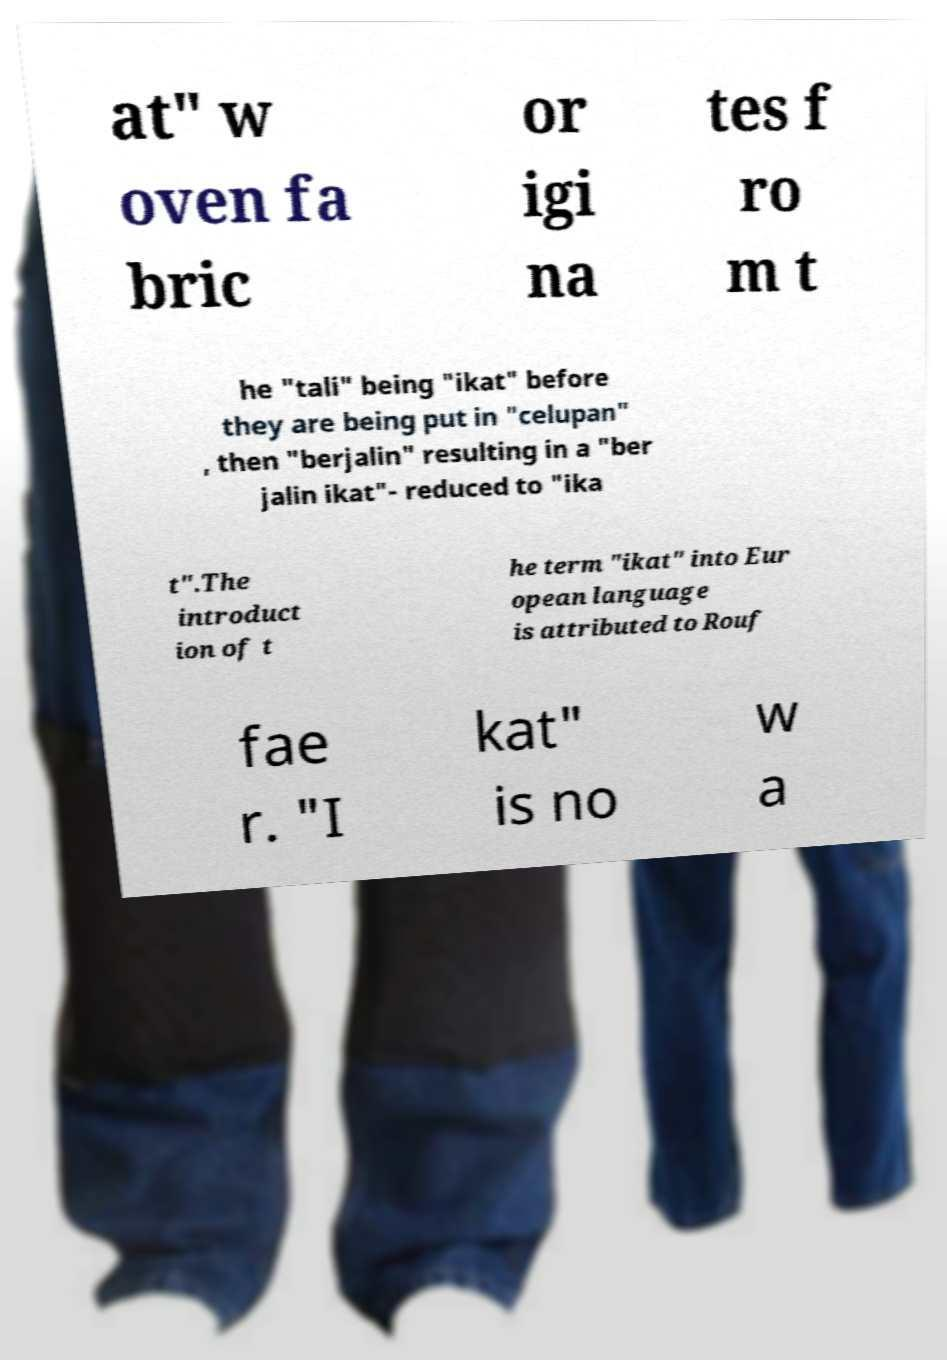What messages or text are displayed in this image? I need them in a readable, typed format. at" w oven fa bric or igi na tes f ro m t he "tali" being "ikat" before they are being put in "celupan" , then "berjalin" resulting in a "ber jalin ikat"- reduced to "ika t".The introduct ion of t he term "ikat" into Eur opean language is attributed to Rouf fae r. "I kat" is no w a 